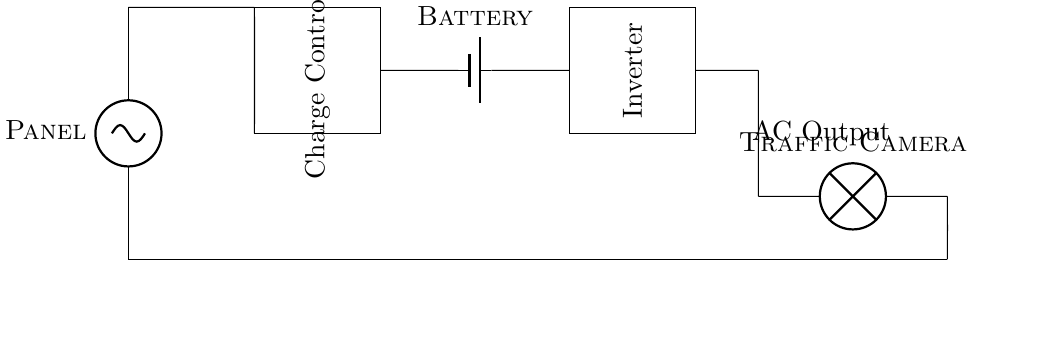What component is used to convert DC to AC? The component used for converting direct current to alternating current in the circuit is the inverter, which is represented in the diagram.
Answer: Inverter What does the charge controller do in this circuit? The charge controller regulates the voltage and current coming from the solar panel to safely charge the battery. It prevents overcharging and ensures optimal charging of the battery.
Answer: Regulates charging What is the purpose of the solar panel in this circuit? The solar panel serves as the primary source of renewable energy, converting sunlight into electrical energy, which powers the system and charges the battery.
Answer: Power source How is the traffic camera powered? The traffic camera is powered by the AC output from the inverter, which converts the power stored in the battery into usable alternating current for the camera operation.
Answer: AC output What is the relationship between the battery and the charge controller? The battery stores the energy that is regulated by the charge controller; the charge controller ensures that the battery is charged with the correct voltage and current, preventing damage.
Answer: Battery stores energy 